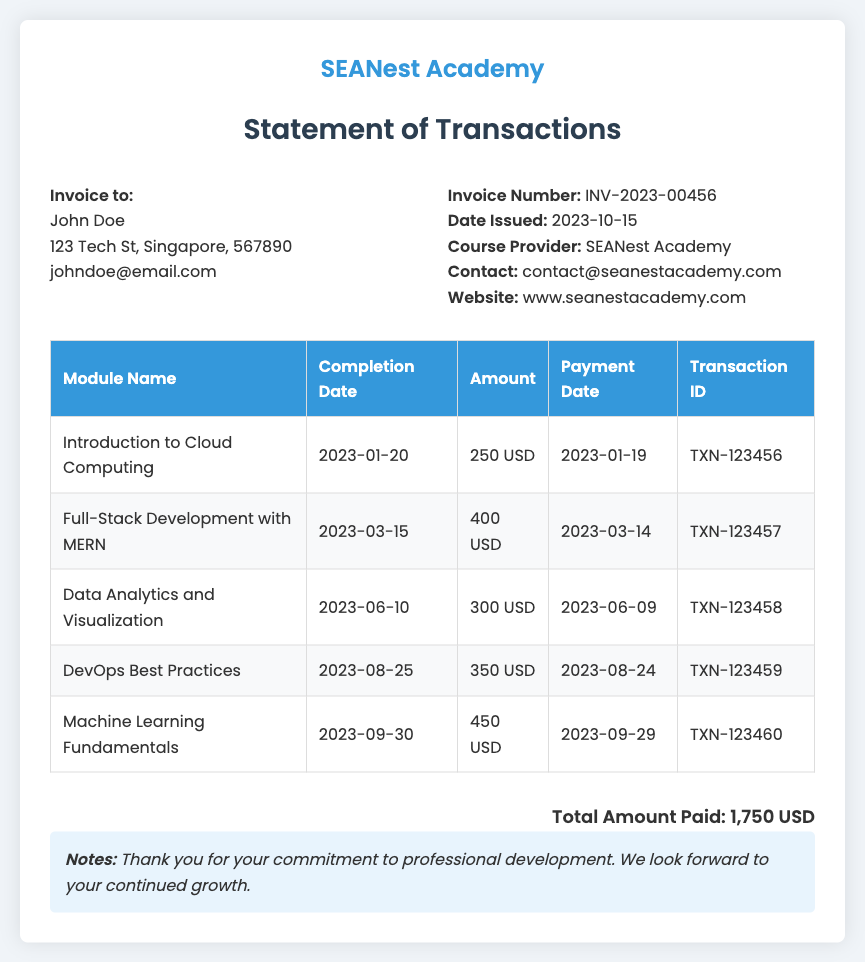What is the invoice number? The invoice number is explicitly stated in the document as a specific identifier for the transaction.
Answer: INV-2023-00456 What is the total amount paid? The total amount paid is a summary figure derived from adding all the amounts in the transaction details.
Answer: 1,750 USD When was the invoice issued? The date issued is a critical piece of information that indicates when the service provider created the invoice.
Answer: 2023-10-15 What is the payment date for the "Machine Learning Fundamentals" module? The payment date for the module is important for tracking the timing of payment for the course.
Answer: 2023-09-29 How many modules were completed in total? This information reflects the count of distinct course modules listed in the transaction document.
Answer: 5 What is the completion date of the "Data Analytics and Visualization" module? This date indicates when the course participant completed this specific module.
Answer: 2023-06-10 What is the transaction ID for the "DevOps Best Practices" module? The transaction ID serves as a unique reference for the payment made for this particular module.
Answer: TXN-123459 Which course provider is listed in the document? The course provider is mentioned, giving insights into who is offering the courses.
Answer: SEANest Academy What was the amount for the "Full-Stack Development with MERN" module? This detailed information specifies the cost associated with this particular course module within the statement.
Answer: 400 USD 